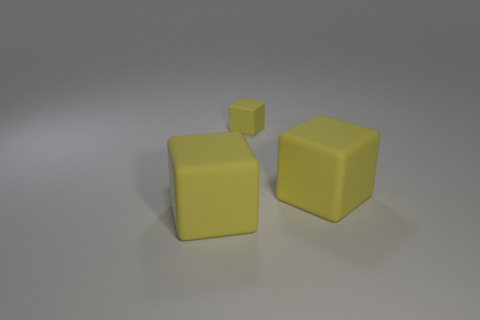What is the color of the tiny matte thing?
Ensure brevity in your answer.  Yellow. Are there any other things that have the same material as the small yellow cube?
Ensure brevity in your answer.  Yes. There is a large object that is behind the rubber thing on the left side of the small thing; what is its shape?
Your response must be concise. Cube. What number of other things are there of the same shape as the small yellow object?
Your answer should be compact. 2. Are there more yellow objects that are left of the small yellow thing than yellow things?
Your response must be concise. No. How many large things are right of the big rubber thing that is on the left side of the tiny rubber object?
Make the answer very short. 1. Are there fewer small matte cubes that are on the left side of the small cube than small blocks?
Provide a short and direct response. Yes. Are there any large yellow rubber things on the left side of the block that is behind the block on the right side of the tiny rubber object?
Your response must be concise. Yes. Is the tiny block made of the same material as the block that is left of the tiny matte block?
Make the answer very short. Yes. What color is the big rubber cube in front of the large cube that is right of the small rubber cube?
Offer a terse response. Yellow. 